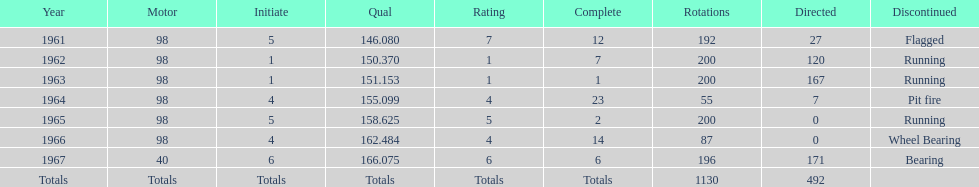What car achieved the highest qual? 40. Help me parse the entirety of this table. {'header': ['Year', 'Motor', 'Initiate', 'Qual', 'Rating', 'Complete', 'Rotations', 'Directed', 'Discontinued'], 'rows': [['1961', '98', '5', '146.080', '7', '12', '192', '27', 'Flagged'], ['1962', '98', '1', '150.370', '1', '7', '200', '120', 'Running'], ['1963', '98', '1', '151.153', '1', '1', '200', '167', 'Running'], ['1964', '98', '4', '155.099', '4', '23', '55', '7', 'Pit fire'], ['1965', '98', '5', '158.625', '5', '2', '200', '0', 'Running'], ['1966', '98', '4', '162.484', '4', '14', '87', '0', 'Wheel Bearing'], ['1967', '40', '6', '166.075', '6', '6', '196', '171', 'Bearing'], ['Totals', 'Totals', 'Totals', 'Totals', 'Totals', 'Totals', '1130', '492', '']]} 